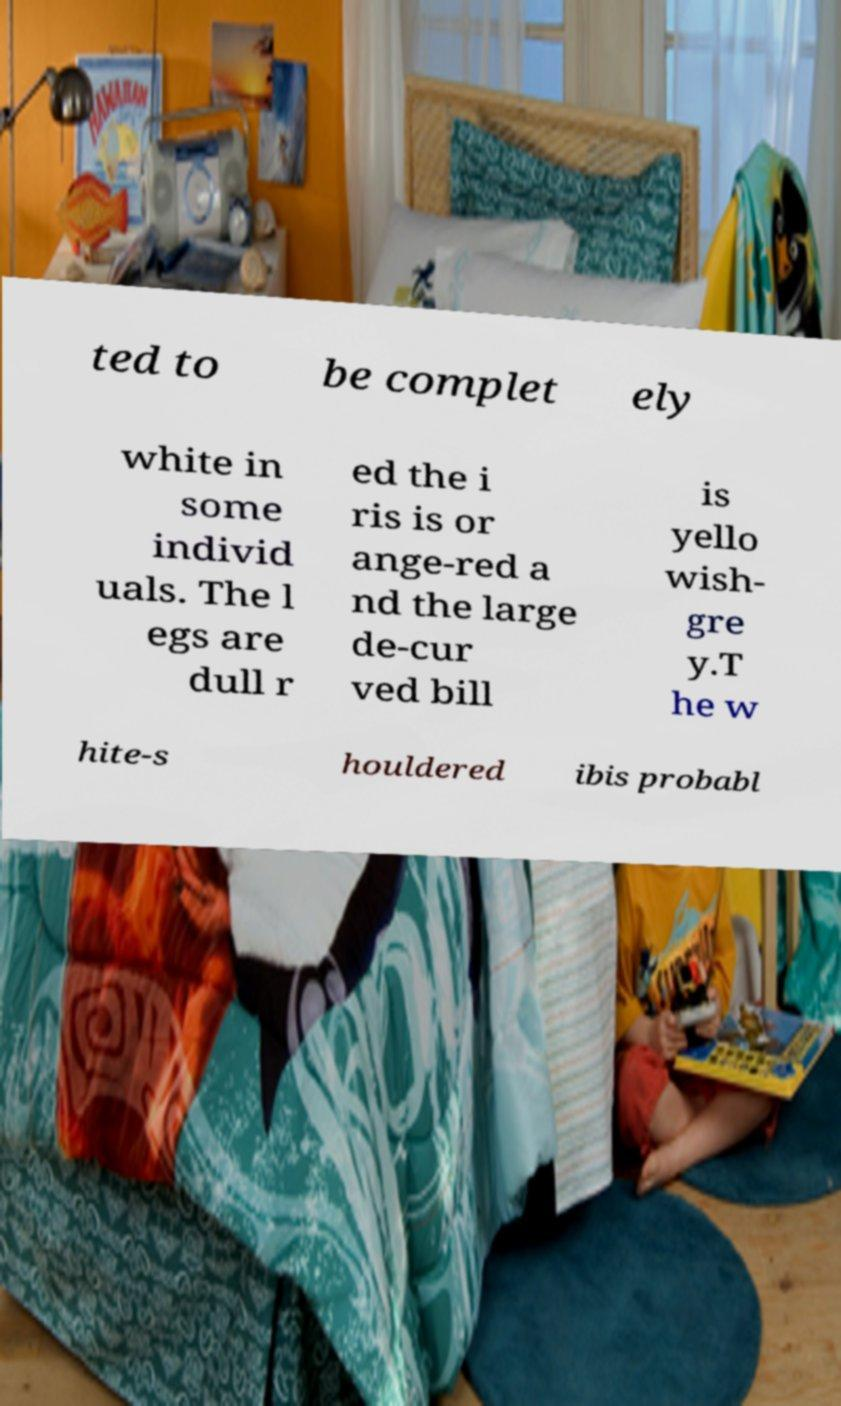What messages or text are displayed in this image? I need them in a readable, typed format. ted to be complet ely white in some individ uals. The l egs are dull r ed the i ris is or ange-red a nd the large de-cur ved bill is yello wish- gre y.T he w hite-s houldered ibis probabl 